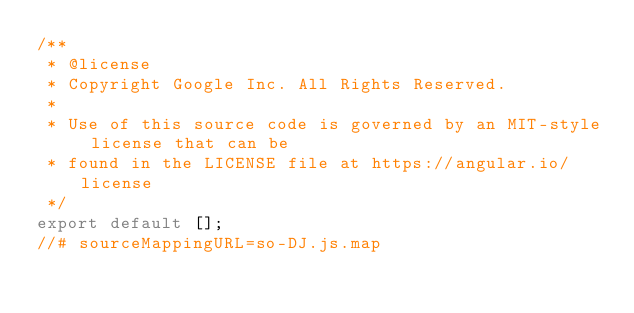Convert code to text. <code><loc_0><loc_0><loc_500><loc_500><_JavaScript_>/**
 * @license
 * Copyright Google Inc. All Rights Reserved.
 *
 * Use of this source code is governed by an MIT-style license that can be
 * found in the LICENSE file at https://angular.io/license
 */
export default [];
//# sourceMappingURL=so-DJ.js.map</code> 